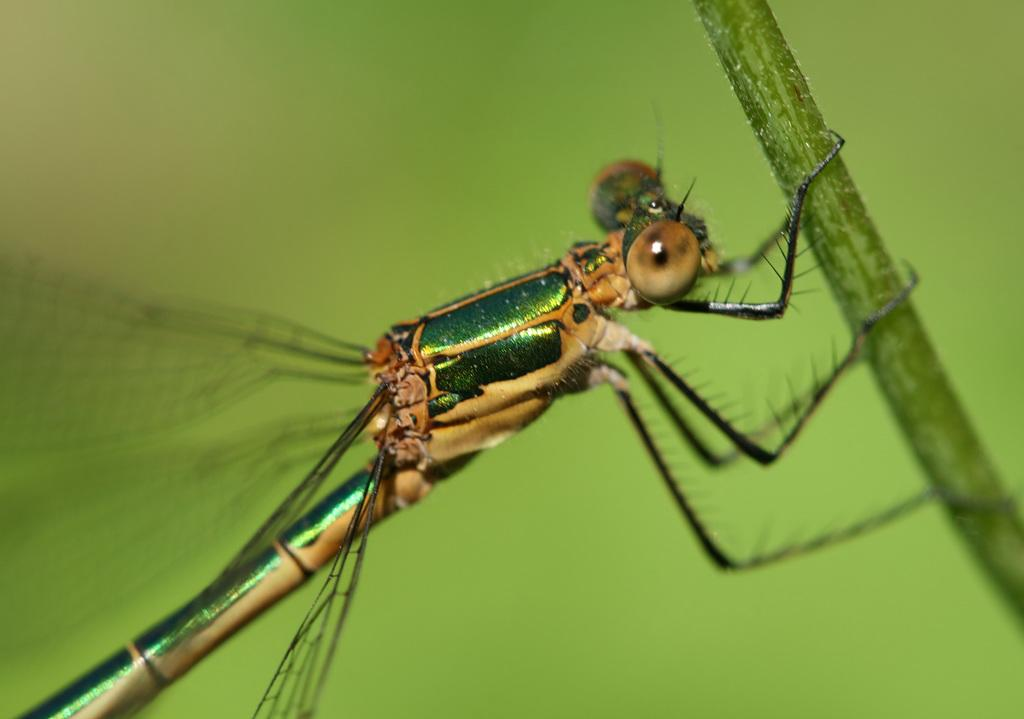What type of creature can be seen in the image? There is an insect in the image. What is the insect sitting on in the image? There is a branch in the image. What color is predominant in the background of the image? The background of the image is green. What type of company is mentioned in the image? There is no company mentioned in the image; it features an insect on a branch with a green background. How many hens are visible in the image? There are no hens present in the image. 